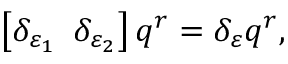<formula> <loc_0><loc_0><loc_500><loc_500>\left [ \delta _ { \varepsilon _ { 1 } } \, \ \delta _ { \varepsilon _ { 2 } } \right ] q ^ { r } = \delta _ { \varepsilon } q ^ { r } ,</formula> 